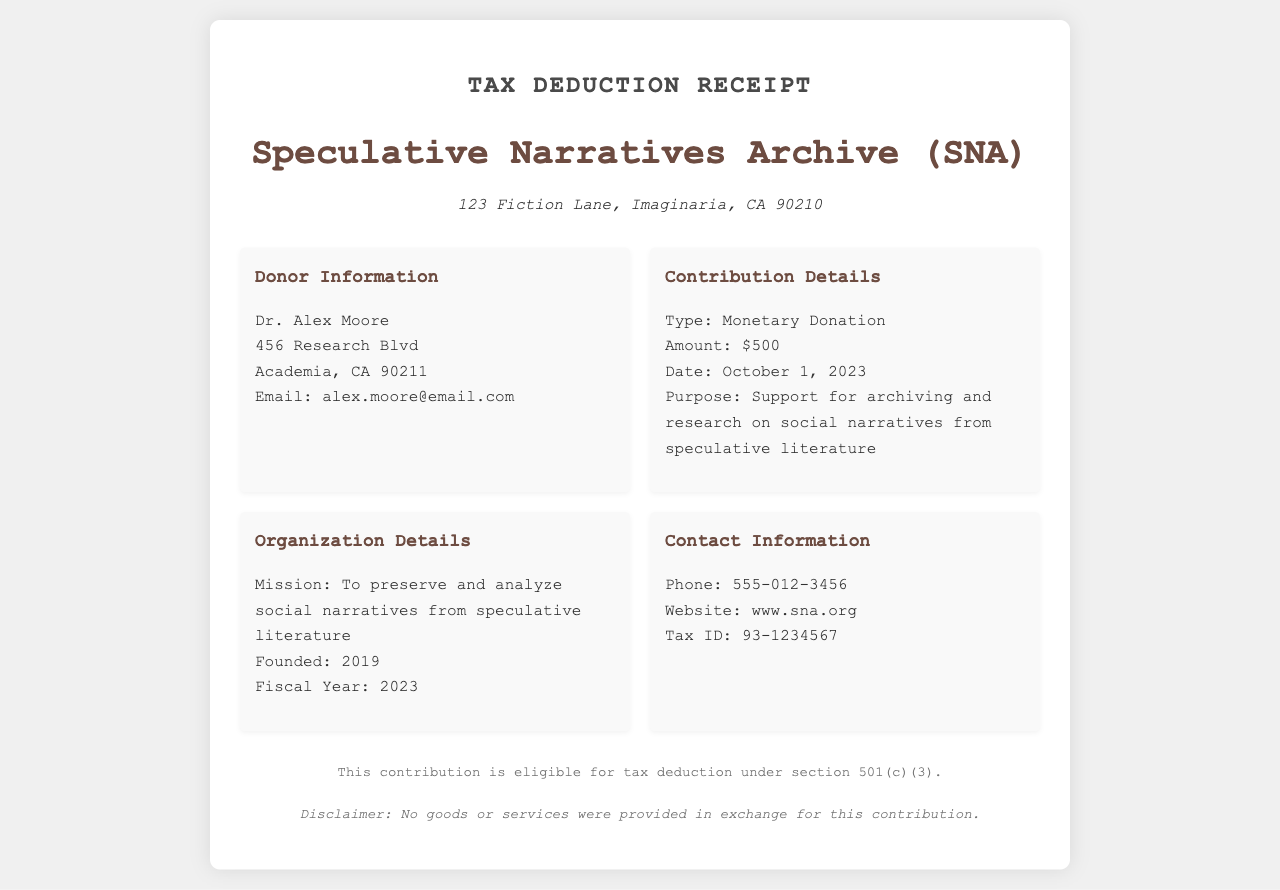What is the organization name? The name of the organization is located in the header section of the document.
Answer: Speculative Narratives Archive (SNA) What is the donor's name? The donor's name can be found in the "Donor Information" section of the document.
Answer: Dr. Alex Moore What was the contribution amount? The contribution amount is detailed in the "Contribution Details" section.
Answer: $500 When was the donation made? The date of the donation is indicated in the "Contribution Details" section.
Answer: October 1, 2023 What is the purpose of the contribution? The purpose is stated in the "Contribution Details" section of the document.
Answer: Support for archiving and research on social narratives from speculative literature What is the organization's mission? The mission of the organization is found in the "Organization Details" section.
Answer: To preserve and analyze social narratives from speculative literature Was any goods or services provided in exchange for the contribution? This information is mentioned in the footer of the document.
Answer: No What is the tax ID of the organization? The tax ID is listed under "Contact Information" in the document.
Answer: 93-1234567 In which year was the organization founded? The founding year is specified in the "Organization Details" section.
Answer: 2019 